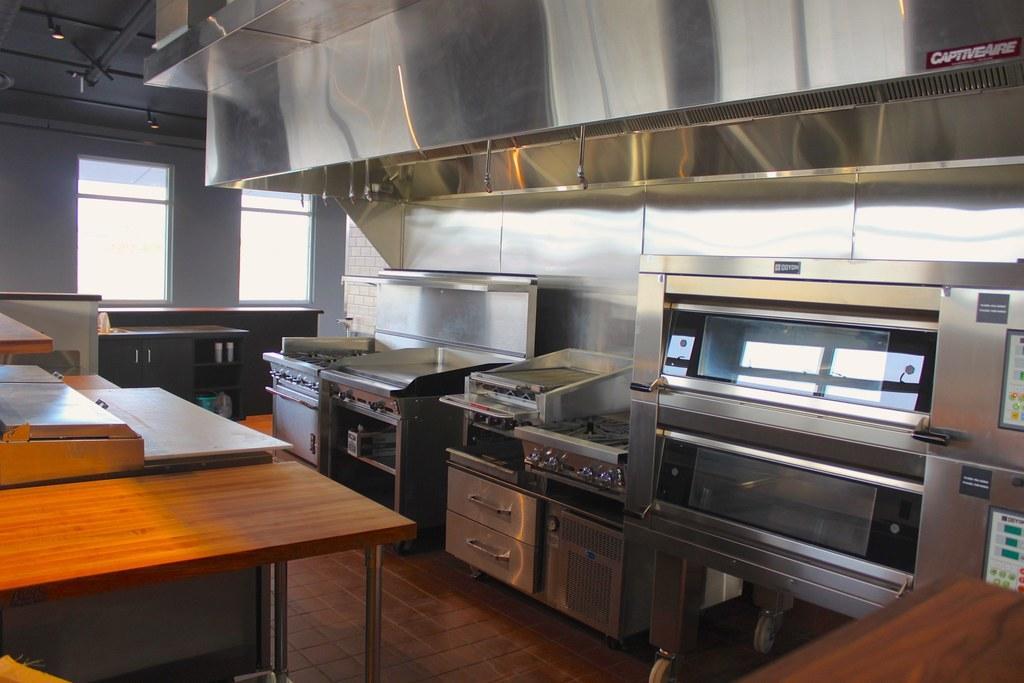How would you summarize this image in a sentence or two? In the image we can see there are machine which are kept on the floor and on table there is a table which is kept. 